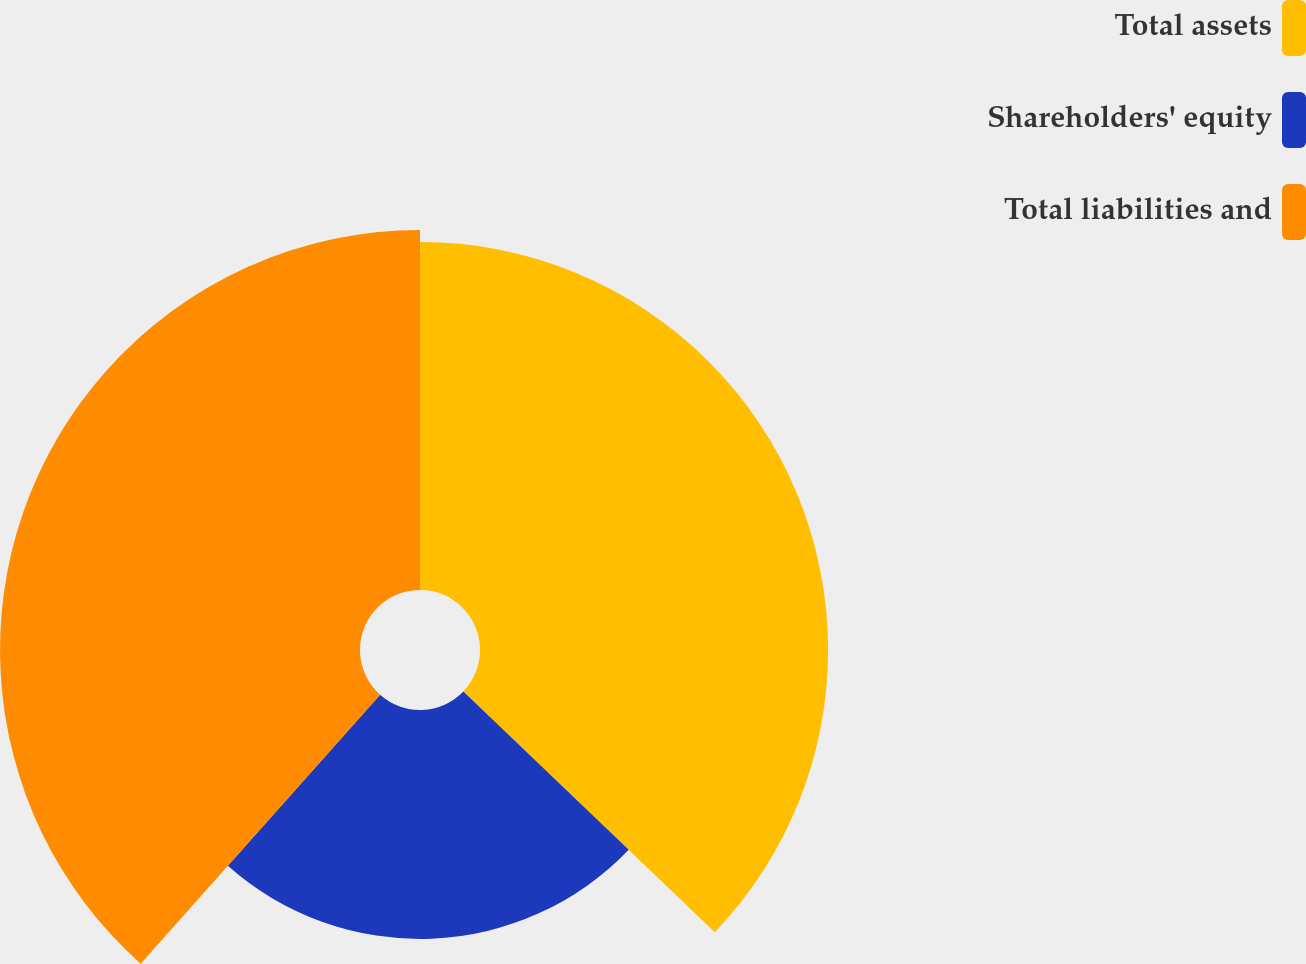<chart> <loc_0><loc_0><loc_500><loc_500><pie_chart><fcel>Total assets<fcel>Shareholders' equity<fcel>Total liabilities and<nl><fcel>37.15%<fcel>24.43%<fcel>38.42%<nl></chart> 